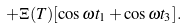Convert formula to latex. <formula><loc_0><loc_0><loc_500><loc_500>+ \Xi ( T ) [ \cos \omega t _ { 1 } + \cos \omega t _ { 3 } ] .</formula> 